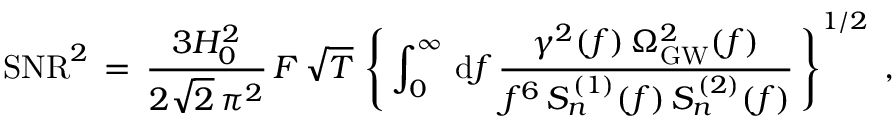<formula> <loc_0><loc_0><loc_500><loc_500>S N R ^ { 2 } \, = \, \frac { 3 H _ { 0 } ^ { 2 } } { 2 \sqrt { 2 } \, \pi ^ { 2 } } \, F \, \sqrt { T } \, \left \{ \, \int _ { 0 } ^ { \infty } \, d f \, \frac { \gamma ^ { 2 } ( f ) \, \Omega _ { G W } ^ { 2 } ( f ) } { f ^ { 6 } \, S _ { n } ^ { \, ( 1 ) } ( f ) \, S _ { n } ^ { \, ( 2 ) } ( f ) } \, \right \} ^ { 1 / 2 } \, ,</formula> 